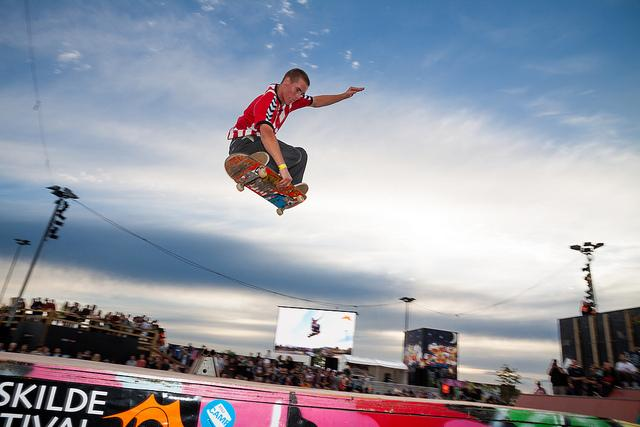What is the name of the trick the man in red is performing? grab 